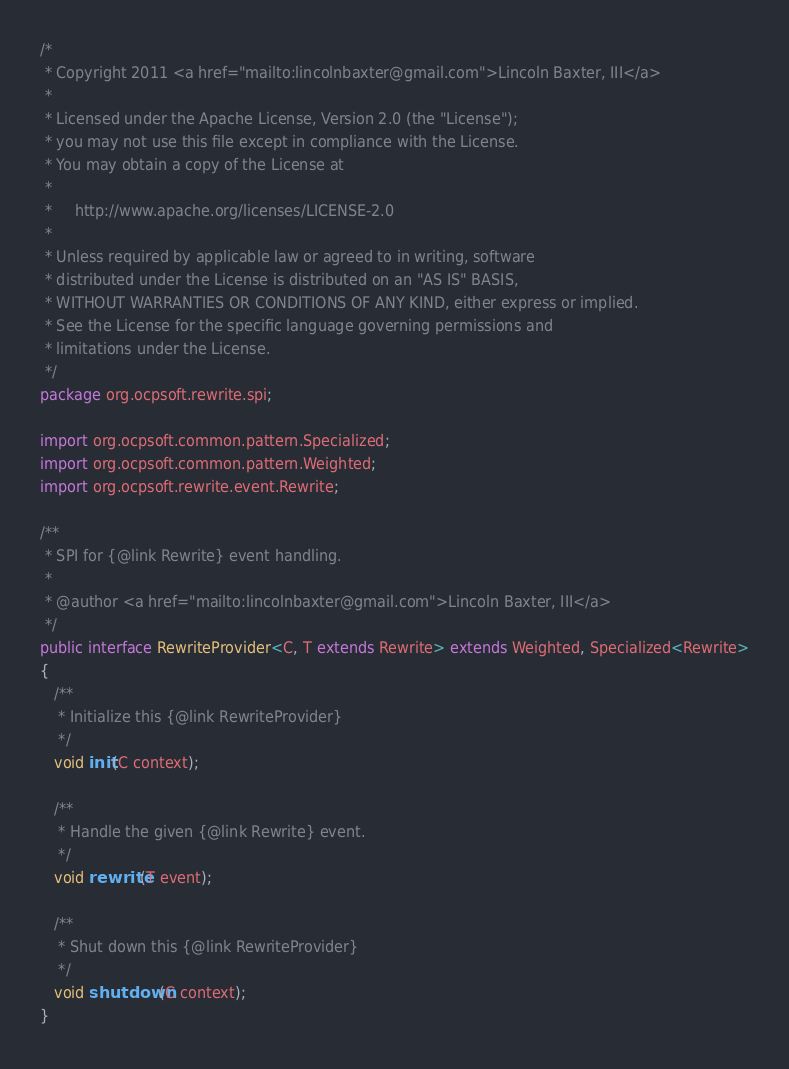Convert code to text. <code><loc_0><loc_0><loc_500><loc_500><_Java_>/*
 * Copyright 2011 <a href="mailto:lincolnbaxter@gmail.com">Lincoln Baxter, III</a>
 *
 * Licensed under the Apache License, Version 2.0 (the "License");
 * you may not use this file except in compliance with the License.
 * You may obtain a copy of the License at
 *
 *     http://www.apache.org/licenses/LICENSE-2.0
 *
 * Unless required by applicable law or agreed to in writing, software
 * distributed under the License is distributed on an "AS IS" BASIS,
 * WITHOUT WARRANTIES OR CONDITIONS OF ANY KIND, either express or implied.
 * See the License for the specific language governing permissions and
 * limitations under the License.
 */
package org.ocpsoft.rewrite.spi;

import org.ocpsoft.common.pattern.Specialized;
import org.ocpsoft.common.pattern.Weighted;
import org.ocpsoft.rewrite.event.Rewrite;

/**
 * SPI for {@link Rewrite} event handling.
 * 
 * @author <a href="mailto:lincolnbaxter@gmail.com">Lincoln Baxter, III</a>
 */
public interface RewriteProvider<C, T extends Rewrite> extends Weighted, Specialized<Rewrite>
{
   /**
    * Initialize this {@link RewriteProvider}
    */
   void init(C context);

   /**
    * Handle the given {@link Rewrite} event.
    */
   void rewrite(T event);

   /**
    * Shut down this {@link RewriteProvider}
    */
   void shutdown(C context);
}
</code> 